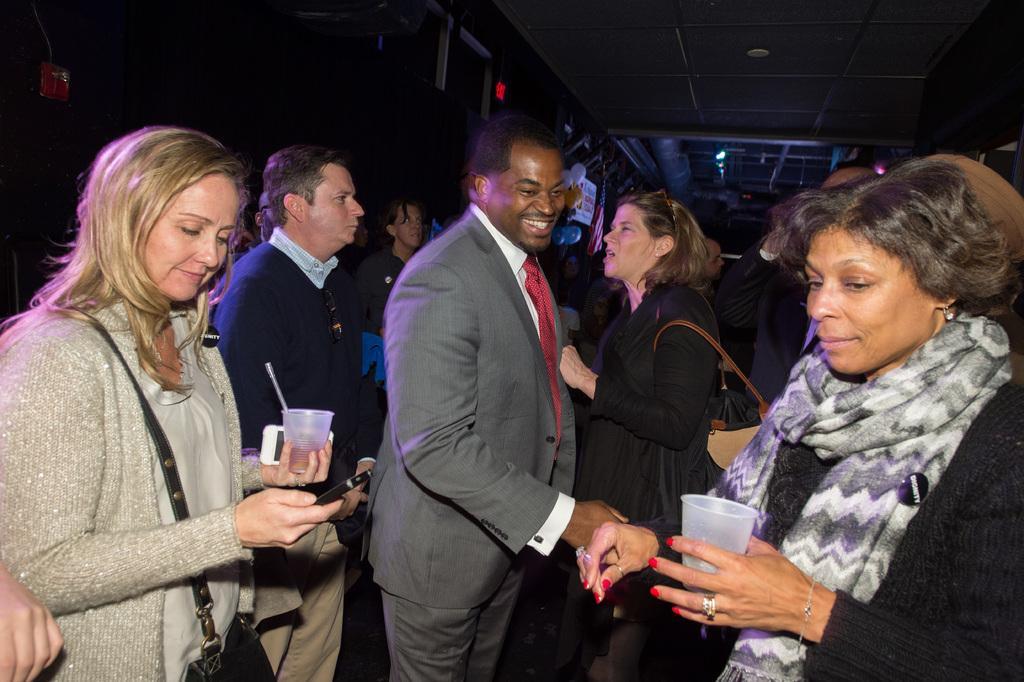Could you give a brief overview of what you see in this image? In the center of the image we can see a man standing and smiling. On the left there is a lady holding a glass and a mobile. On the right we can see another lady. In the background there are people. At the top there are lights. 